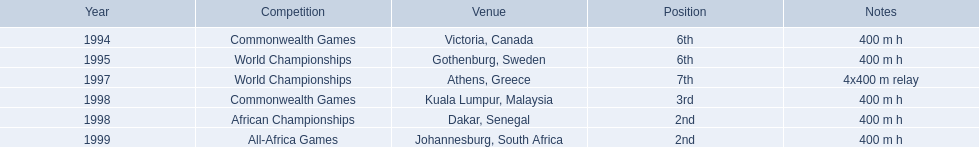What races did ken harden run? 400 m h, 400 m h, 4x400 m relay, 400 m h, 400 m h, 400 m h. Which race did ken harden run in 1997? 4x400 m relay. 